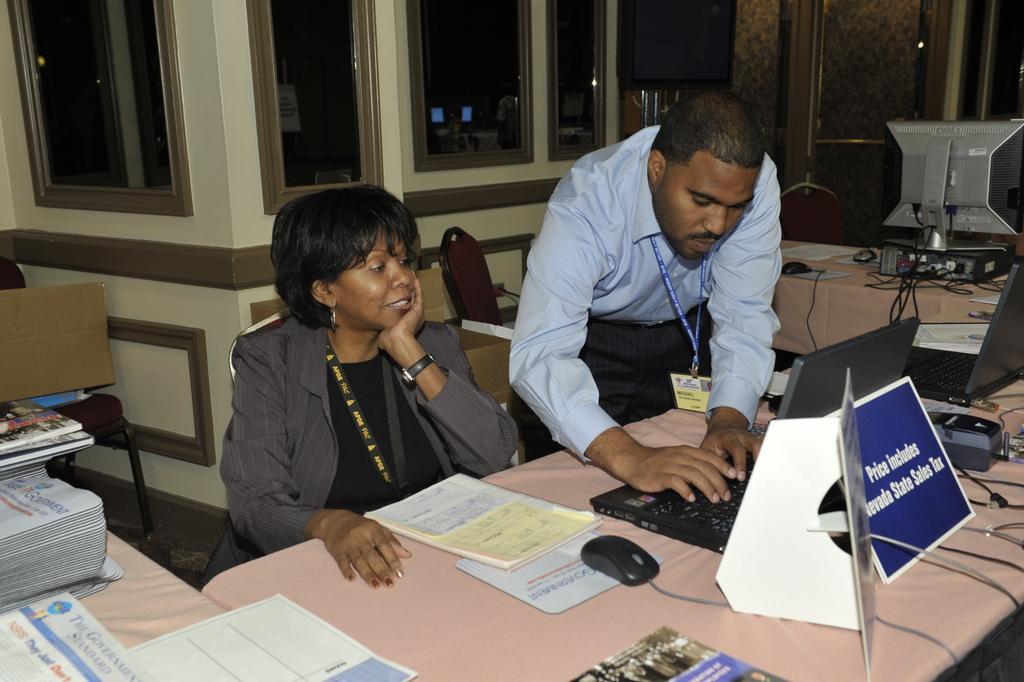Can you describe this image briefly? In this image I can see the two people with different color dresses. I can see the tables in-front of these people. On the tables I can see the laptops, books, papers and many mice. In the background I can see the chairs, black color object and the glass windows. 